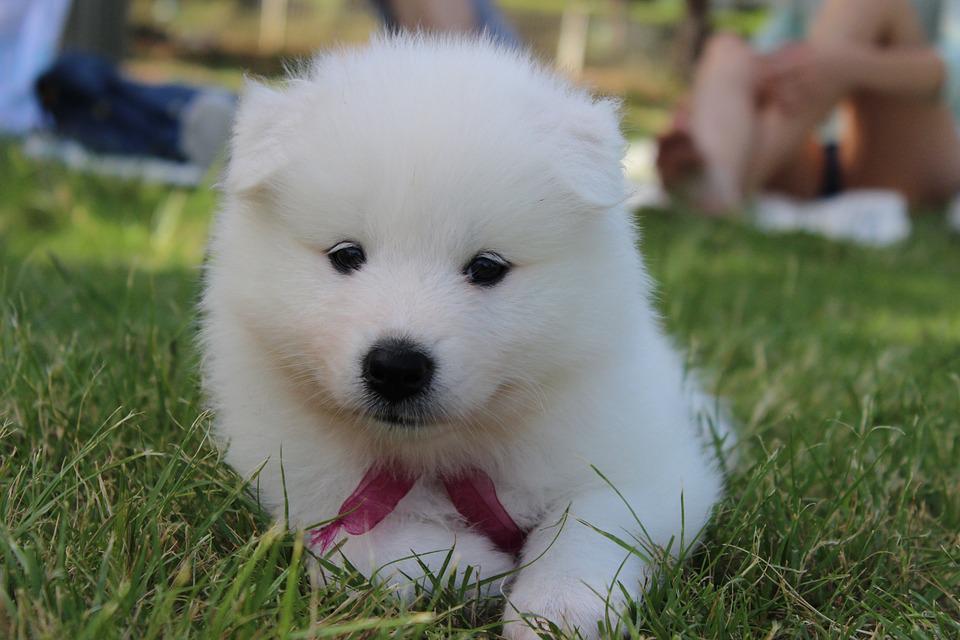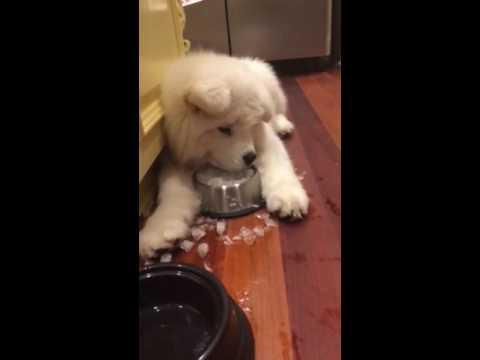The first image is the image on the left, the second image is the image on the right. For the images displayed, is the sentence "a dog is sitting at the kitchen table" factually correct? Answer yes or no. No. The first image is the image on the left, the second image is the image on the right. Given the left and right images, does the statement "There is a total of 2 Samoyed's sitting at a table." hold true? Answer yes or no. No. 